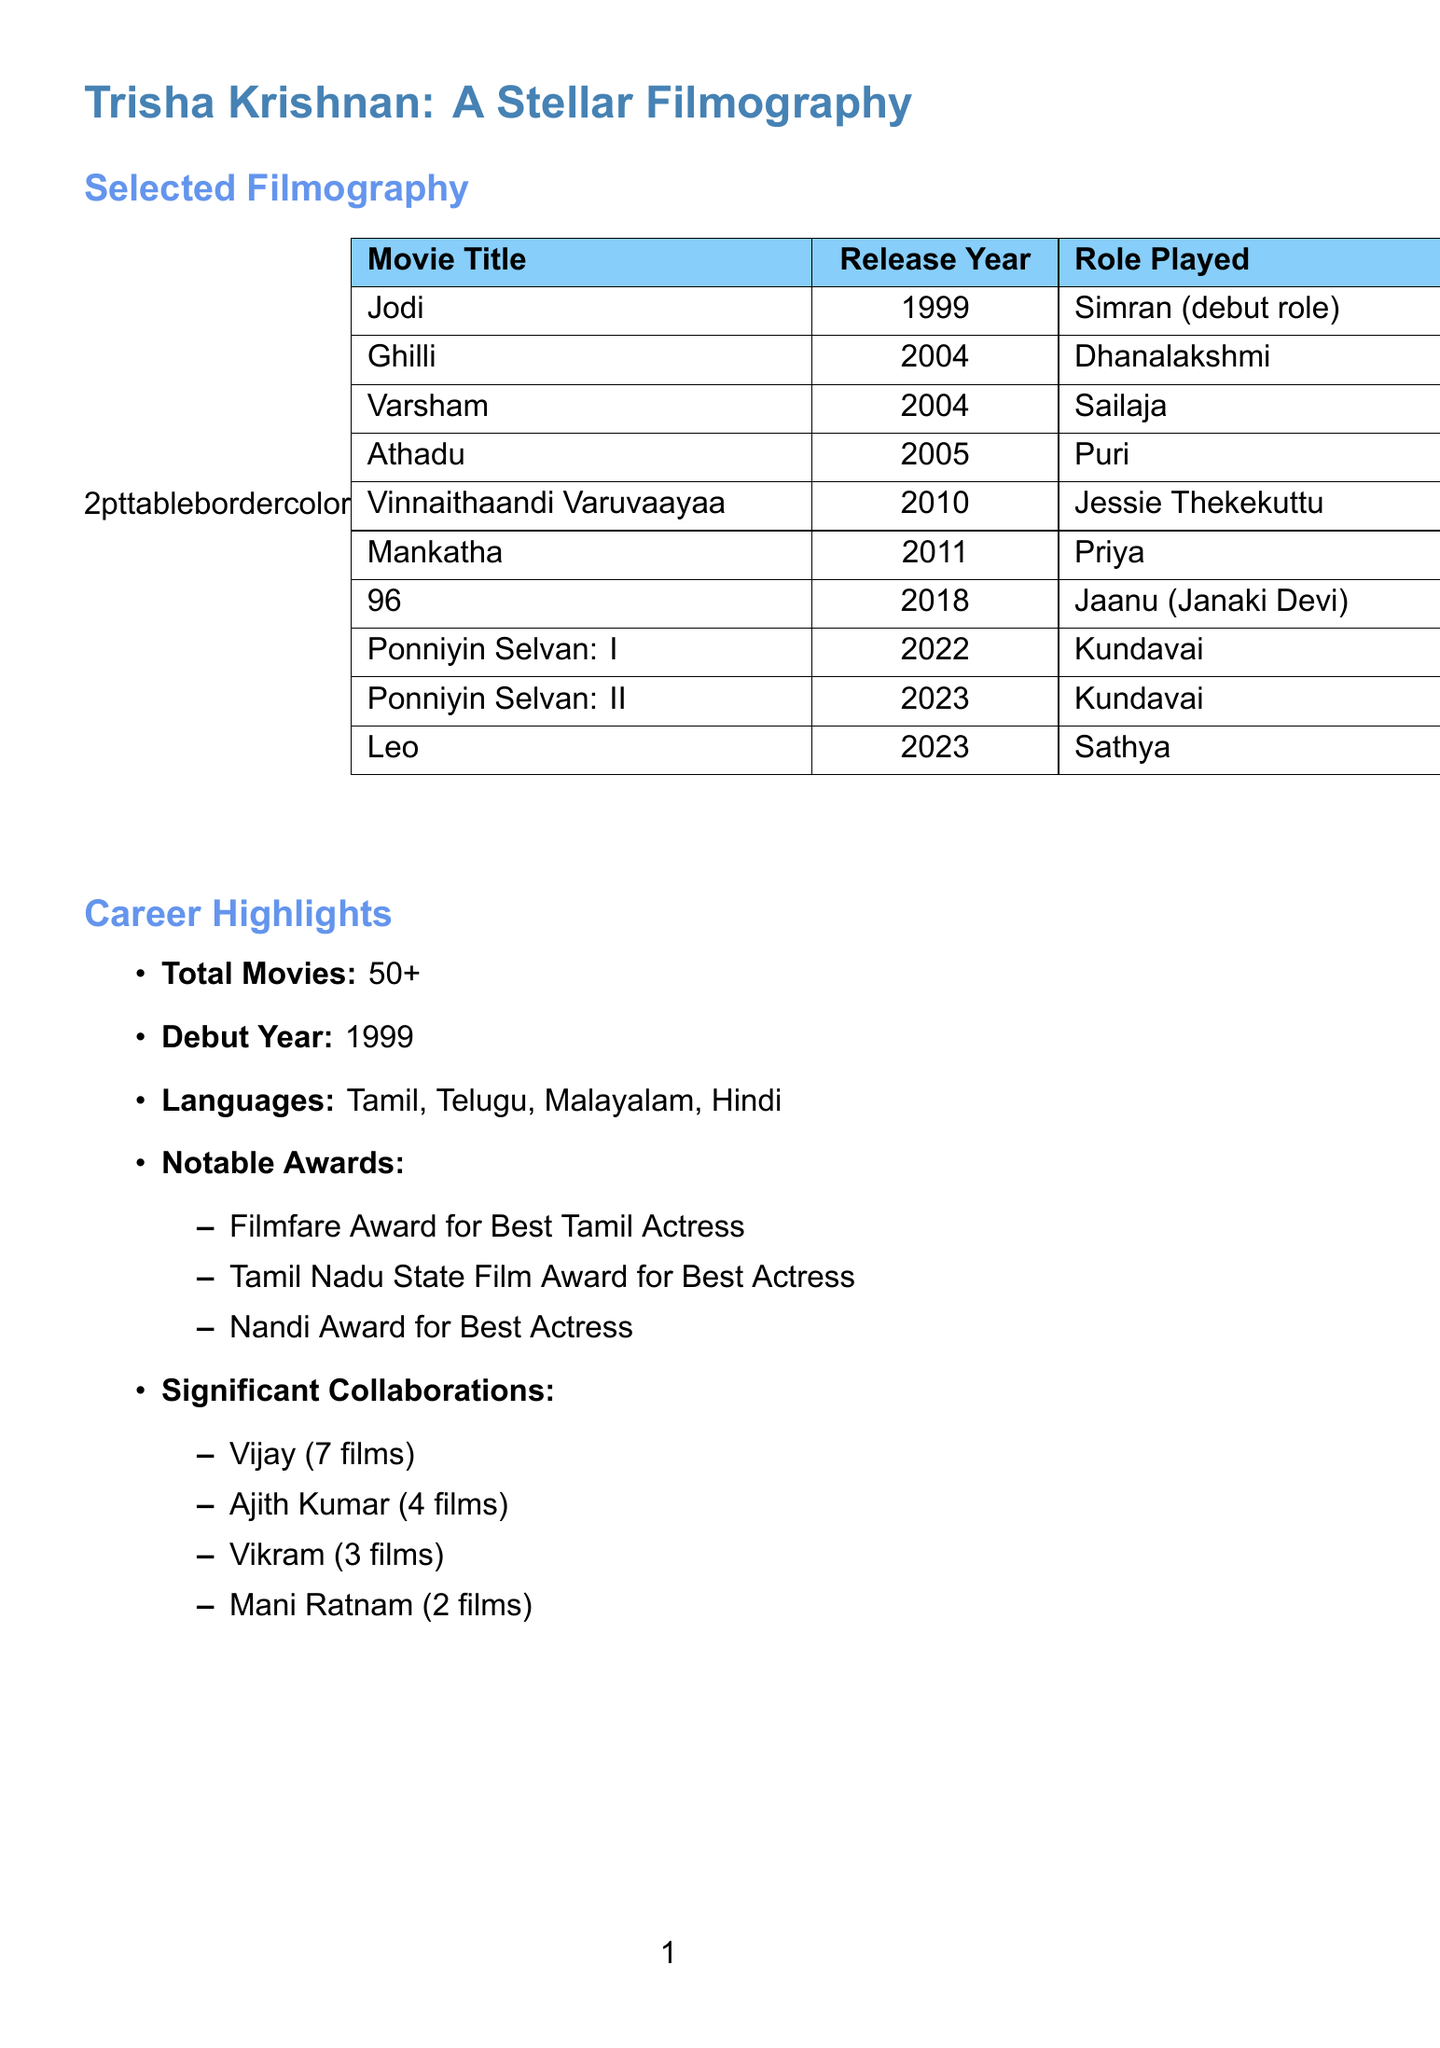What is Trisha's debut movie? Trisha's debut movie is mentioned in the document, which is "Jodi."
Answer: Jodi In what year was "Mounam Pesiyadhe" released? The release year for "Mounam Pesiyadhe" is provided in the filmography checklist.
Answer: 2002 Who played the character Sailaja? The document specifies that Trisha played the role of Sailaja in the movie "Varsham."
Answer: Trisha How many significant collaborations does Trisha have with Vijay? The document states that Trisha has collaborated with Vijay in 7 films.
Answer: 7 films What role did Trisha play in "Petta"? Trisha's role in "Petta" is listed in the document, which identifies her character as Saro.
Answer: Saro Which award is mentioned in the notable awards section? The document includes various awards, and one of them is the Filmfare Award for Best Tamil Actress.
Answer: Filmfare Award for Best Tamil Actress What is the total number of movies Trisha has done? The total number of movies Trisha has acted in is explicitly stated in the document.
Answer: 50+ What languages has Trisha worked in? The document lists the languages Trisha has worked in, providing a clear answer.
Answer: Tamil, Telugu, Malayalam, Hindi What is the role of Trisha in the movie "96"? The document provides her character name in "96," which is mentioned explicitly.
Answer: Jaanu (Janaki Devi) 